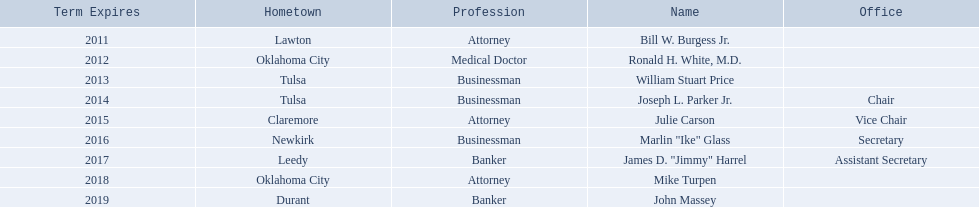What businessmen were born in tulsa? William Stuart Price, Joseph L. Parker Jr. Which man, other than price, was born in tulsa? Joseph L. Parker Jr. 